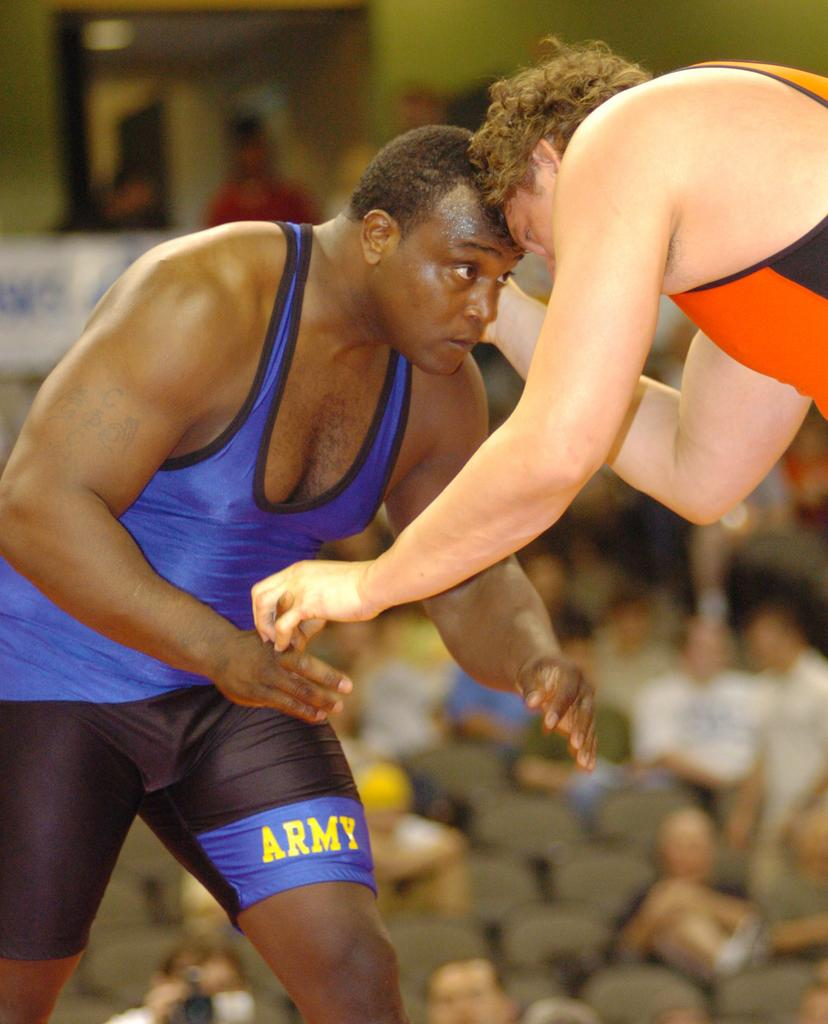<image>
Summarize the visual content of the image. Army is the team name displayed on the shorts of this wrestler. 